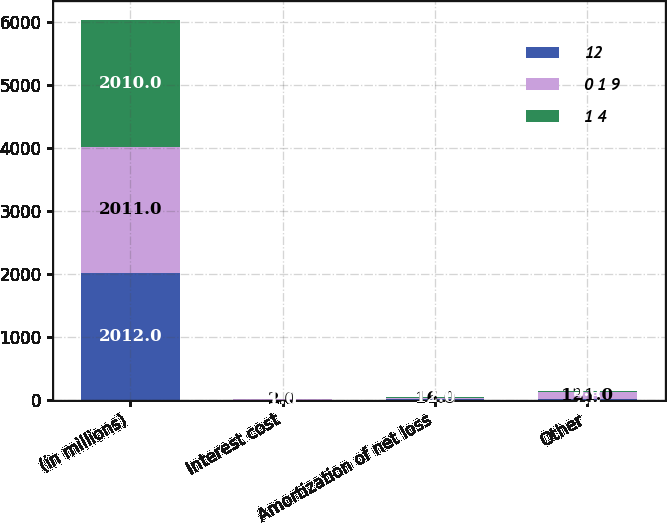Convert chart. <chart><loc_0><loc_0><loc_500><loc_500><stacked_bar_chart><ecel><fcel>(in millions)<fcel>Interest cost<fcel>Amortization of net loss<fcel>Other<nl><fcel>12<fcel>2012<fcel>1<fcel>17<fcel>7<nl><fcel>0 1 9<fcel>2011<fcel>2<fcel>16<fcel>121<nl><fcel>1 4<fcel>2010<fcel>1<fcel>12<fcel>5<nl></chart> 